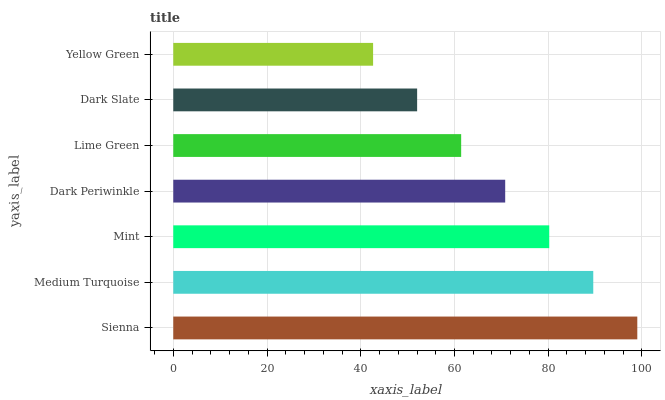Is Yellow Green the minimum?
Answer yes or no. Yes. Is Sienna the maximum?
Answer yes or no. Yes. Is Medium Turquoise the minimum?
Answer yes or no. No. Is Medium Turquoise the maximum?
Answer yes or no. No. Is Sienna greater than Medium Turquoise?
Answer yes or no. Yes. Is Medium Turquoise less than Sienna?
Answer yes or no. Yes. Is Medium Turquoise greater than Sienna?
Answer yes or no. No. Is Sienna less than Medium Turquoise?
Answer yes or no. No. Is Dark Periwinkle the high median?
Answer yes or no. Yes. Is Dark Periwinkle the low median?
Answer yes or no. Yes. Is Dark Slate the high median?
Answer yes or no. No. Is Mint the low median?
Answer yes or no. No. 